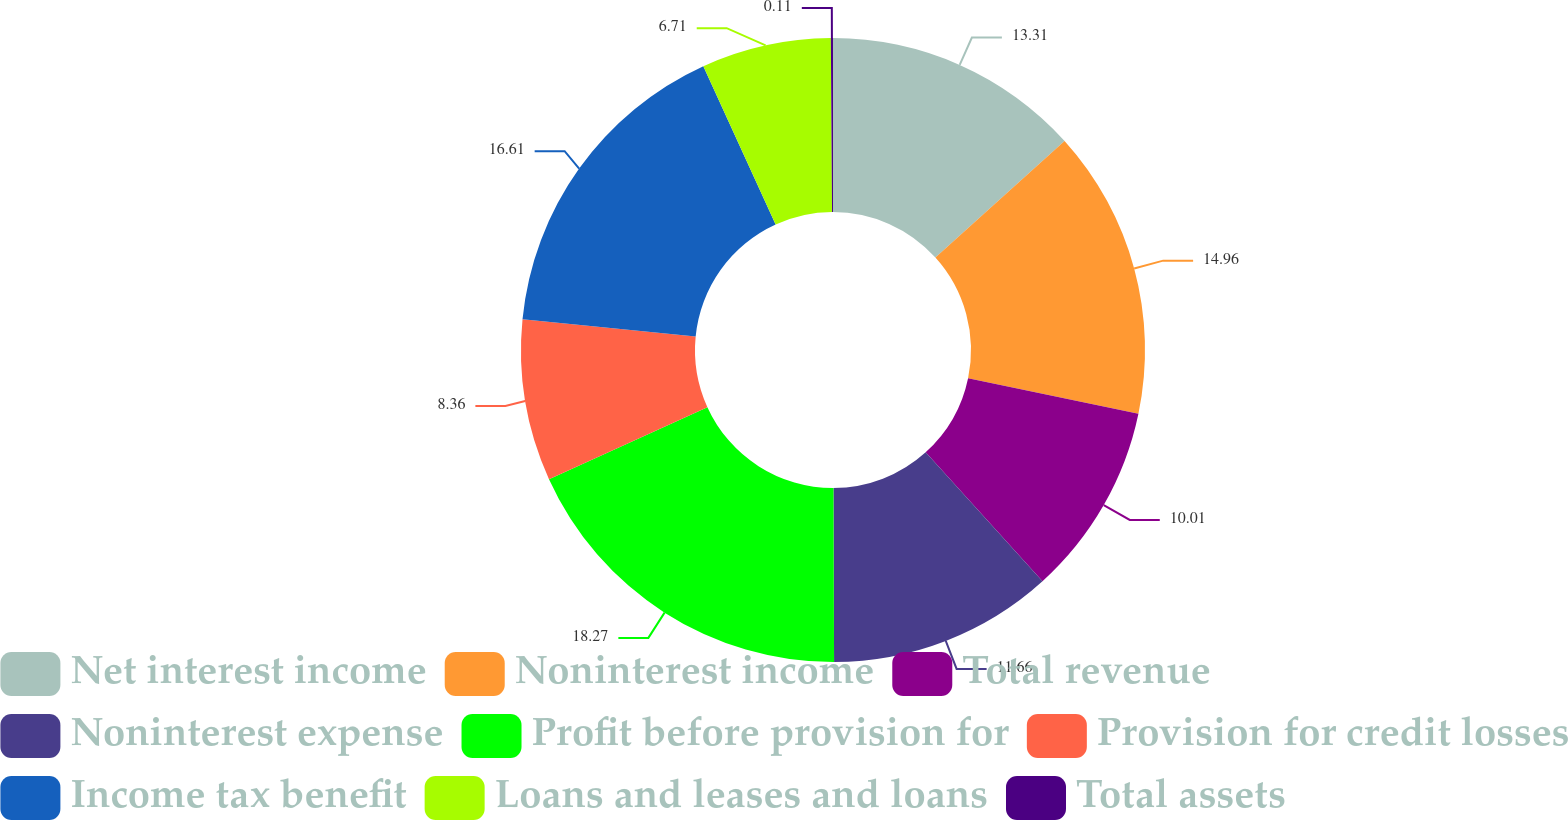Convert chart to OTSL. <chart><loc_0><loc_0><loc_500><loc_500><pie_chart><fcel>Net interest income<fcel>Noninterest income<fcel>Total revenue<fcel>Noninterest expense<fcel>Profit before provision for<fcel>Provision for credit losses<fcel>Income tax benefit<fcel>Loans and leases and loans<fcel>Total assets<nl><fcel>13.31%<fcel>14.96%<fcel>10.01%<fcel>11.66%<fcel>18.26%<fcel>8.36%<fcel>16.61%<fcel>6.71%<fcel>0.11%<nl></chart> 